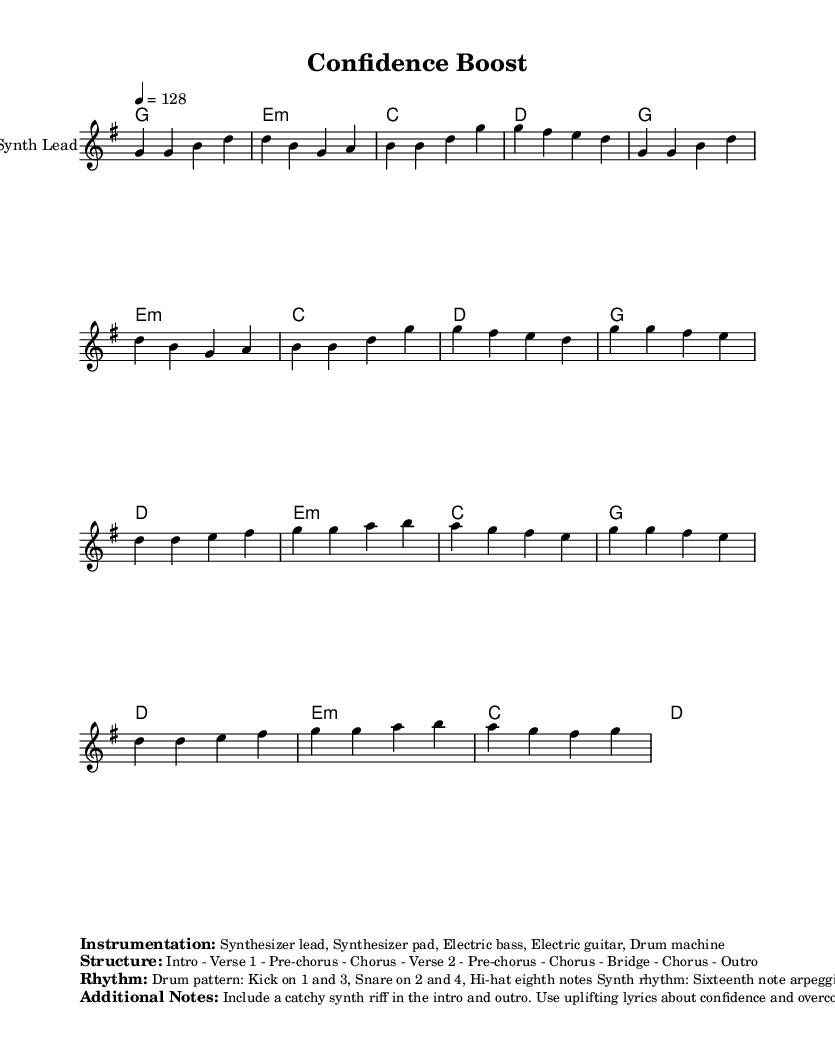What is the key signature of this music? The key signature is G major, indicated by one sharp (F#) at the beginning of the staff.
Answer: G major What is the time signature of this piece? The time signature is 4/4, as shown at the beginning of the music which denotes four beats per measure.
Answer: 4/4 What is the tempo marking for the piece? The tempo marking indicates 128 beats per minute, reflecting a moderately fast pace suitable for energetic tracks.
Answer: 128 How many sections are there in the structure? The structure includes several distinct sections: Intro, Verse 1, Pre-chorus, Chorus, Verse 2, Pre-chorus, Chorus, Bridge, Chorus, and Outro, which totals 10 sections.
Answer: 10 Which instruments are used in the arrangement? The arrangement features a synthesizer lead, synthesizer pad, electric bass, electric guitar, and a drum machine, showcasing the common instrumentation found in K-pop tracks.
Answer: Synthesizer lead, synthesizer pad, electric bass, electric guitar, drum machine What is the drum pattern described in the music? The drum pattern consists of a kick drum on beats 1 and 3, a snare on beats 2 and 4, and a hi-hat playing eighth notes, which provides a strong rhythmic foundation typical for dance tracks.
Answer: Kick on 1 and 3, Snare on 2 and 4, Hi-hat eighth notes What is the defining characteristic of the chorus in this piece? The chorus features catchy synth riffs and additional vocal ad-libs and harmonies, creating an uplifting and energetic atmosphere suitable for boosting confidence before public speaking.
Answer: Uplifting lyrics, catchy synth riff 